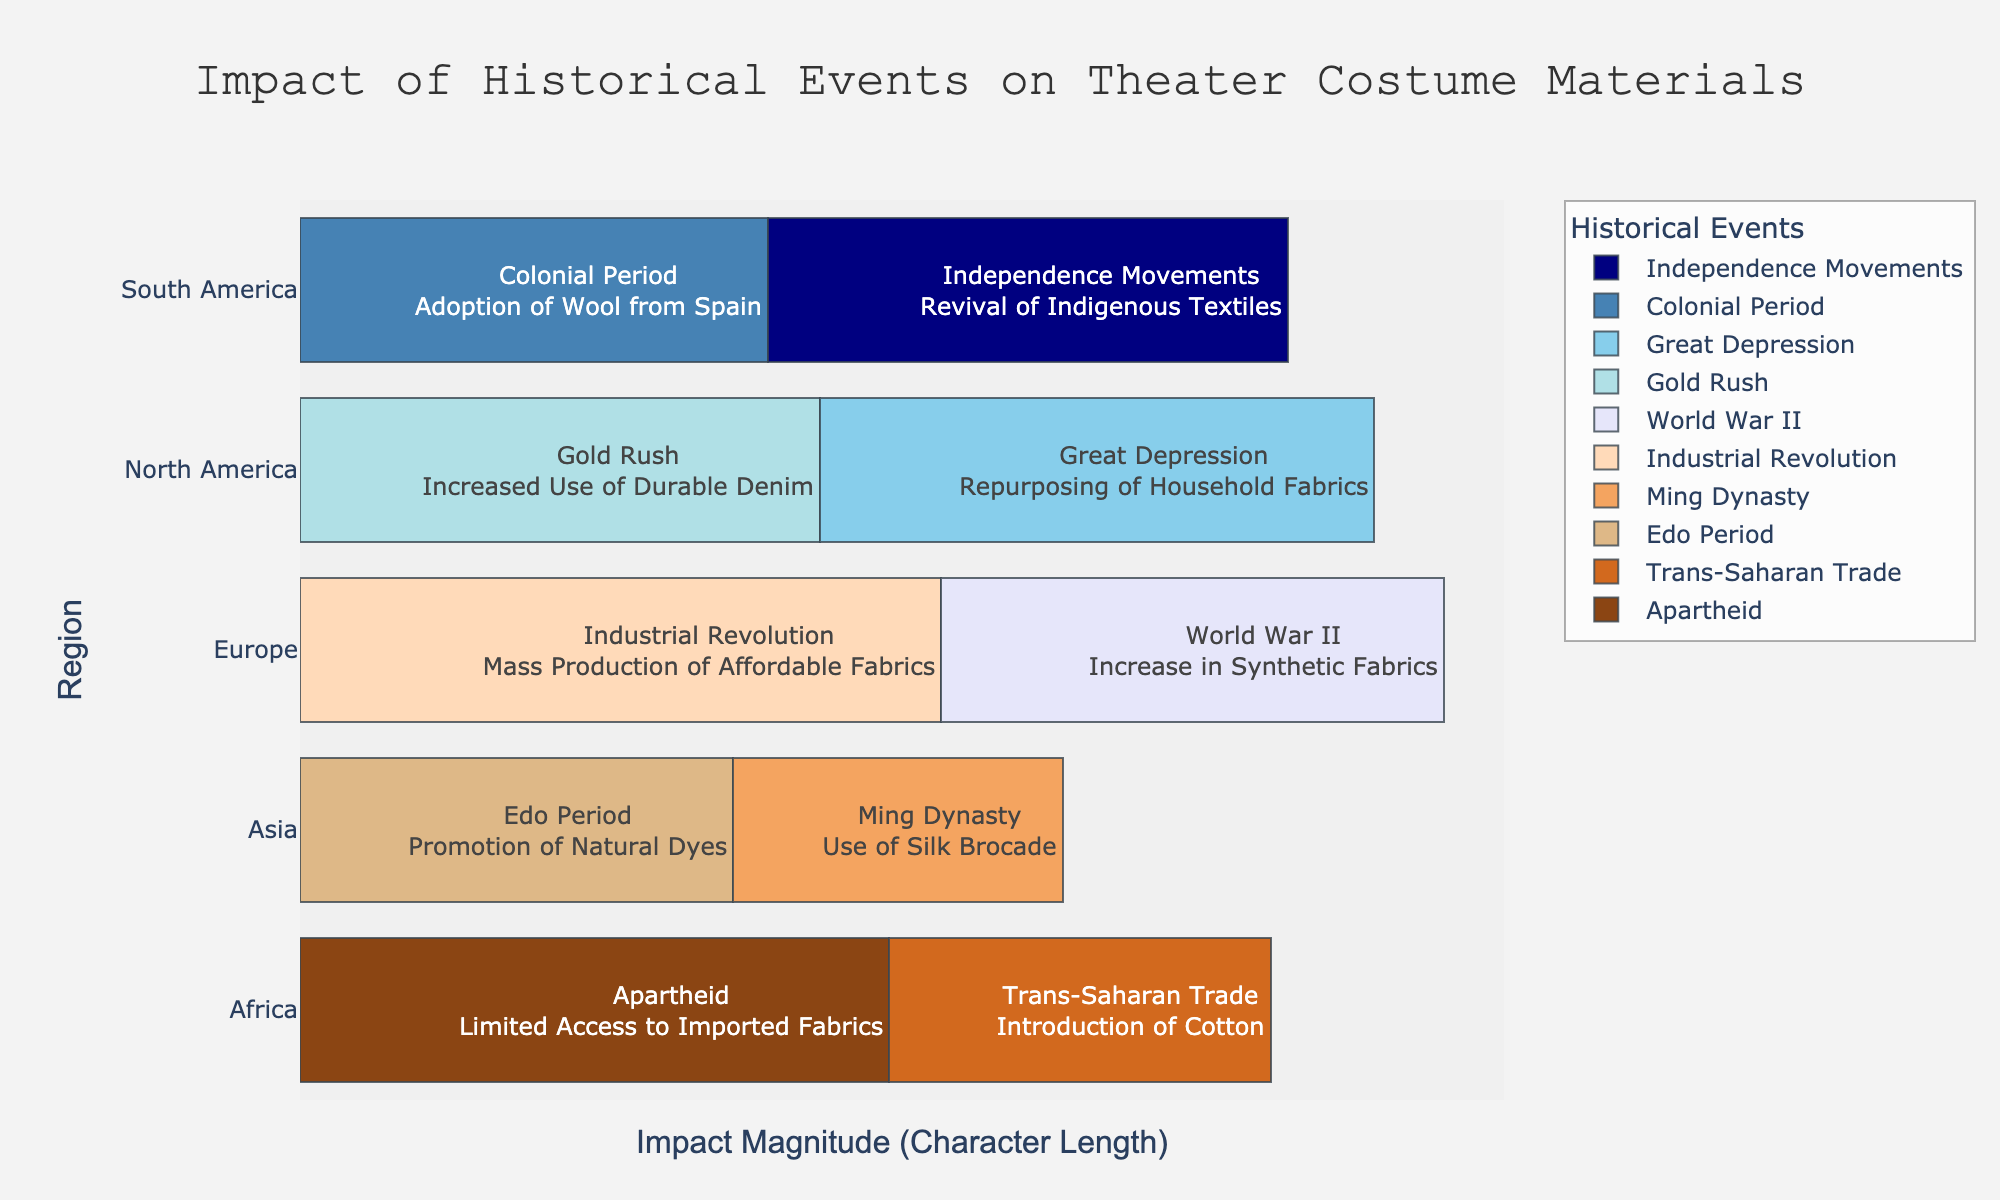What historical event had the greatest impact on theater costume materials in Europe? The figure shows two events in Europe: World War II and Industrial Revolution. To determine the greatest impact, compare the impact descriptions. "Increase in Synthetic Fabrics" is a simpler change than "Mass Production of Affordable Fabrics" which implies a broader and more extensive change.
Answer: Industrial Revolution Which region experienced the most diverse impacts on theater costume materials due to historical events? To answer this, we compare the number of different impacts described for each region. North America and Africa each have two distinct impacts, while the other regions have only one each.
Answer: North America and Africa What impact did the Trans-Saharan Trade have on African theater costume materials? Locate the bar labeled "Trans-Saharan Trade" under the Africa region. The text indicates that the Trans-Saharan Trade led to the introduction of cotton.
Answer: Introduction of Cotton How did the Great Depression affect theater costume materials in North America? Find the bar for "Great Depression" under the North America region. The text explains that during this period, there was the repurposing of household fabrics.
Answer: Repurposing of Household Fabrics Which historical event is associated with the use of Silk Brocade in theater costumes? Identify the event connected to the use of Silk Brocade by finding the corresponding bar. Under Asia, the event is the Ming Dynasty.
Answer: Ming Dynasty Compare the use of natural versus synthetic materials influenced by historical events in Asia. Examine the impacts on materials in Asia. The Ming Dynasty led to the use of Silk Brocade (natural), and the Edo Period promoted natural dyes (natural). No synthetic materials were mentioned for Asia.
Answer: Natural materials Which regions have historical events leading to an increased use of imported materials? Look for the regions with impacts related to imported materials. The Trans-Saharan Trade in Africa introduced cotton, and the Colonial Period in South America led to the adoption of wool from Spain.
Answer: Africa and South America What are the colors used to represent Europe in the figure? Identify the color bars corresponding to Europe by examining the colors for the "World War II" and "Industrial Revolution" events. The colors are brown and navy blue, respectively.
Answer: Brown and navy blue How has Apartheid affected the access to theater costume materials in Africa? Under the Africa region, the bar for Apartheid indicates a limited access to imported fabrics.
Answer: Limited access to imported fabrics Which historical event in South America led to a revival of indigenous textiles? Locate the bar under South America for the revival of indigenous textiles. The related event is the Independence Movements.
Answer: Independence Movements 